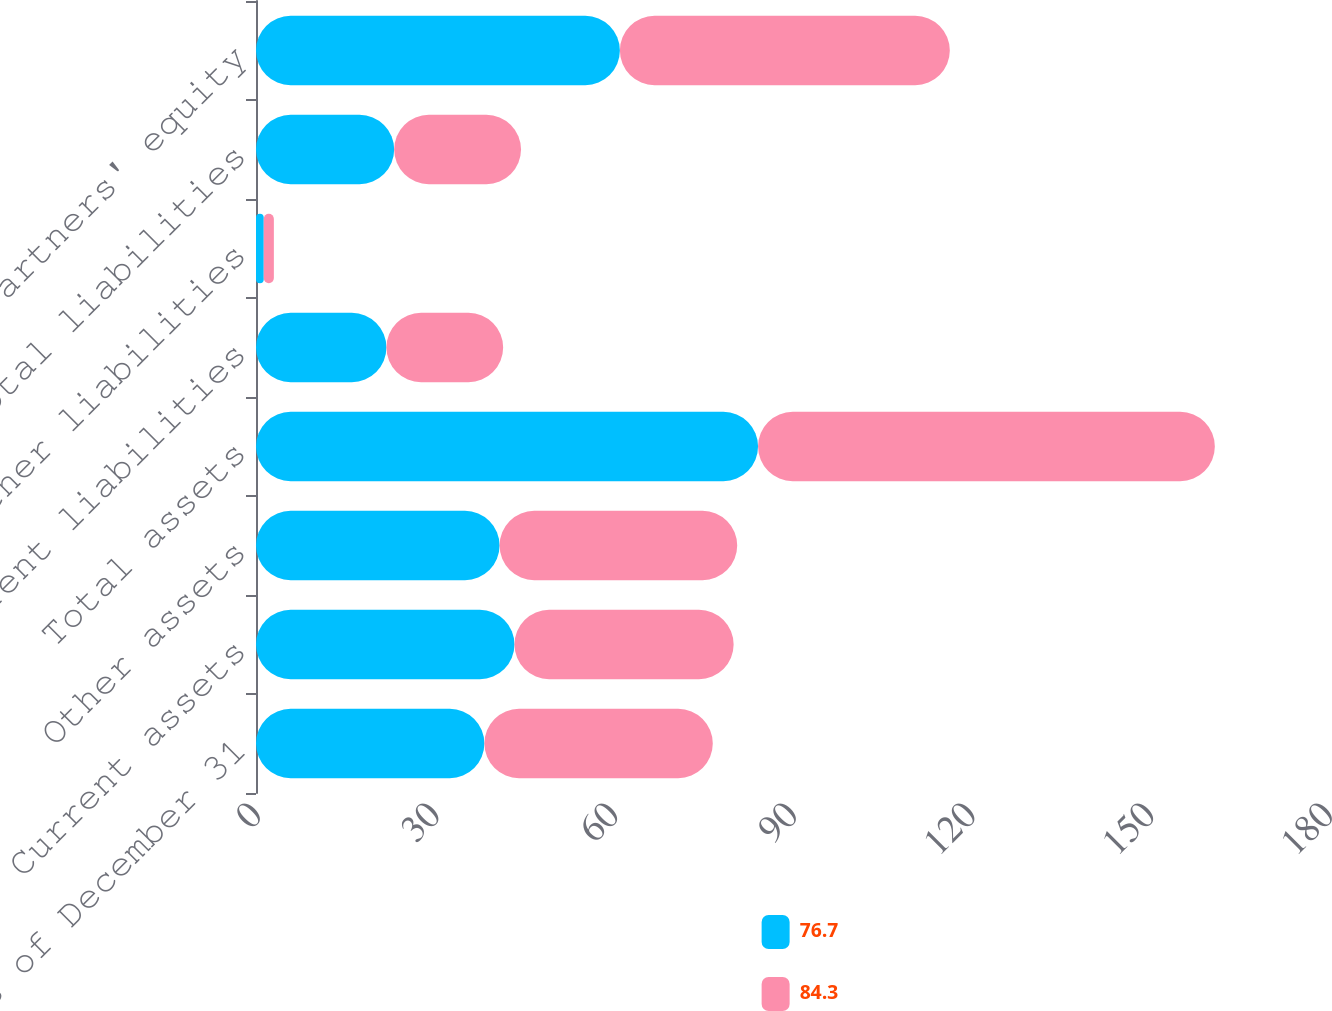<chart> <loc_0><loc_0><loc_500><loc_500><stacked_bar_chart><ecel><fcel>As of December 31<fcel>Current assets<fcel>Other assets<fcel>Total assets<fcel>Current liabilities<fcel>Other liabilities<fcel>Total liabilities<fcel>Partners' equity<nl><fcel>76.7<fcel>38.35<fcel>43.4<fcel>40.9<fcel>84.3<fcel>21.9<fcel>1.3<fcel>23.2<fcel>61.1<nl><fcel>84.3<fcel>38.35<fcel>36.8<fcel>39.9<fcel>76.7<fcel>19.6<fcel>1.7<fcel>21.3<fcel>55.4<nl></chart> 